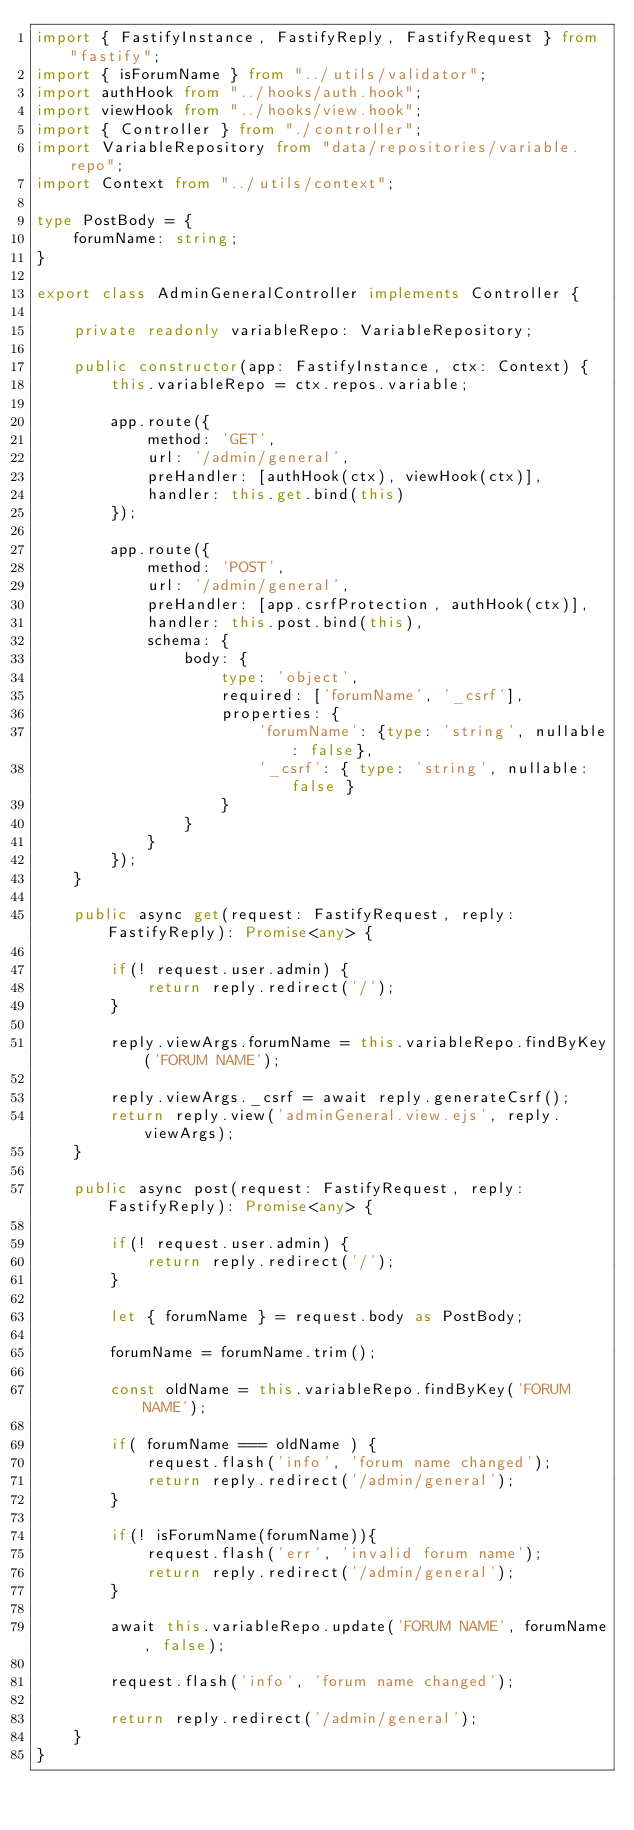Convert code to text. <code><loc_0><loc_0><loc_500><loc_500><_TypeScript_>import { FastifyInstance, FastifyReply, FastifyRequest } from "fastify";
import { isForumName } from "../utils/validator";
import authHook from "../hooks/auth.hook";
import viewHook from "../hooks/view.hook";
import { Controller } from "./controller";
import VariableRepository from "data/repositories/variable.repo";
import Context from "../utils/context";

type PostBody = {
    forumName: string;
}

export class AdminGeneralController implements Controller {

    private readonly variableRepo: VariableRepository;

    public constructor(app: FastifyInstance, ctx: Context) {
        this.variableRepo = ctx.repos.variable;

        app.route({
            method: 'GET',
            url: '/admin/general',
            preHandler: [authHook(ctx), viewHook(ctx)],
            handler: this.get.bind(this)
        });

        app.route({
            method: 'POST',
            url: '/admin/general',
            preHandler: [app.csrfProtection, authHook(ctx)],
            handler: this.post.bind(this),
            schema: {
                body: {
                    type: 'object',
                    required: ['forumName', '_csrf'],
                    properties: {
                        'forumName': {type: 'string', nullable: false},
                        '_csrf': { type: 'string', nullable: false }
                    }
                }
            }
        });
    }

    public async get(request: FastifyRequest, reply: FastifyReply): Promise<any> {
        
        if(! request.user.admin) {
            return reply.redirect('/');
        }

        reply.viewArgs.forumName = this.variableRepo.findByKey('FORUM NAME');

        reply.viewArgs._csrf = await reply.generateCsrf();
        return reply.view('adminGeneral.view.ejs', reply.viewArgs);
    }

    public async post(request: FastifyRequest, reply: FastifyReply): Promise<any> {
    
        if(! request.user.admin) {
            return reply.redirect('/');
        }

        let { forumName } = request.body as PostBody;

        forumName = forumName.trim();

        const oldName = this.variableRepo.findByKey('FORUM NAME');

        if( forumName === oldName ) {
            request.flash('info', 'forum name changed');
            return reply.redirect('/admin/general');
        }

        if(! isForumName(forumName)){
            request.flash('err', 'invalid forum name');
            return reply.redirect('/admin/general');
        }

        await this.variableRepo.update('FORUM NAME', forumName, false);

        request.flash('info', 'forum name changed');

        return reply.redirect('/admin/general');
    }
}</code> 